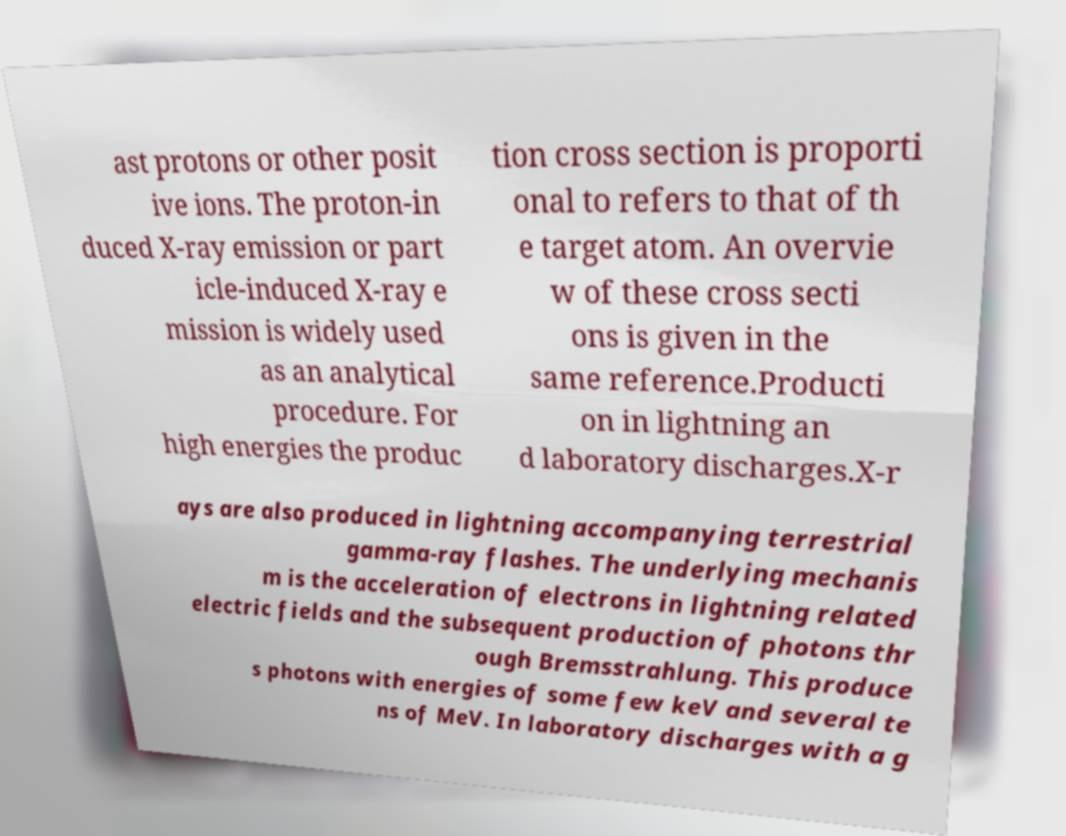For documentation purposes, I need the text within this image transcribed. Could you provide that? ast protons or other posit ive ions. The proton-in duced X-ray emission or part icle-induced X-ray e mission is widely used as an analytical procedure. For high energies the produc tion cross section is proporti onal to refers to that of th e target atom. An overvie w of these cross secti ons is given in the same reference.Producti on in lightning an d laboratory discharges.X-r ays are also produced in lightning accompanying terrestrial gamma-ray flashes. The underlying mechanis m is the acceleration of electrons in lightning related electric fields and the subsequent production of photons thr ough Bremsstrahlung. This produce s photons with energies of some few keV and several te ns of MeV. In laboratory discharges with a g 